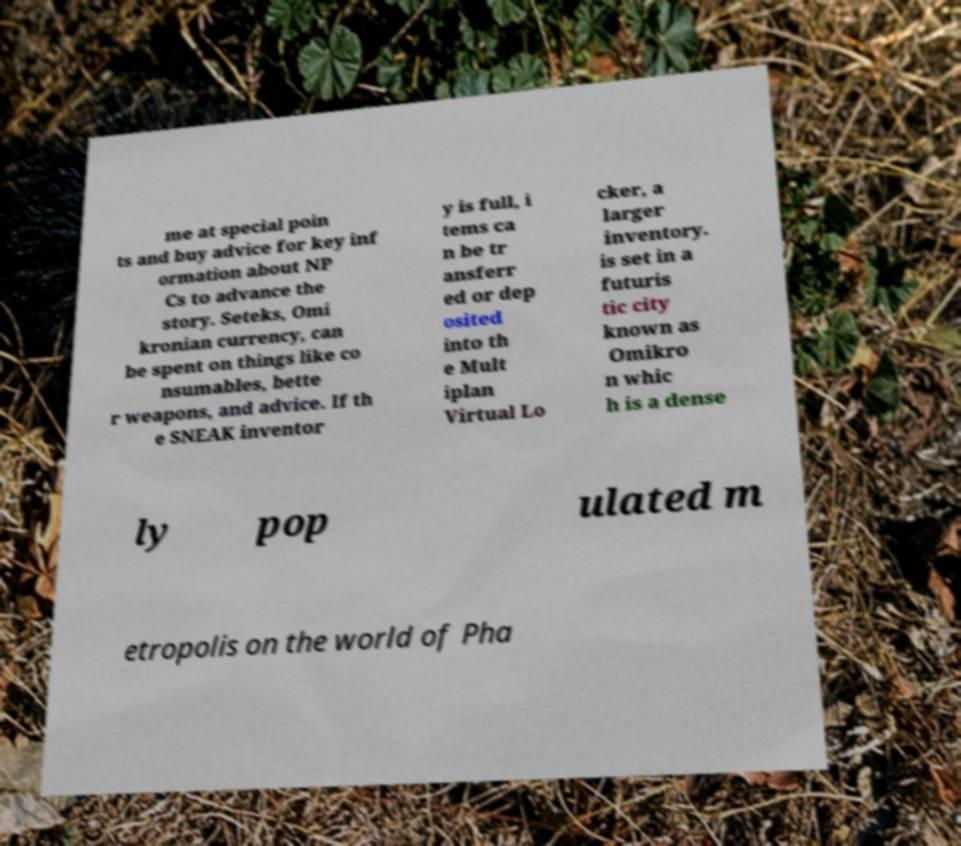Could you assist in decoding the text presented in this image and type it out clearly? me at special poin ts and buy advice for key inf ormation about NP Cs to advance the story. Seteks, Omi kronian currency, can be spent on things like co nsumables, bette r weapons, and advice. If th e SNEAK inventor y is full, i tems ca n be tr ansferr ed or dep osited into th e Mult iplan Virtual Lo cker, a larger inventory. is set in a futuris tic city known as Omikro n whic h is a dense ly pop ulated m etropolis on the world of Pha 